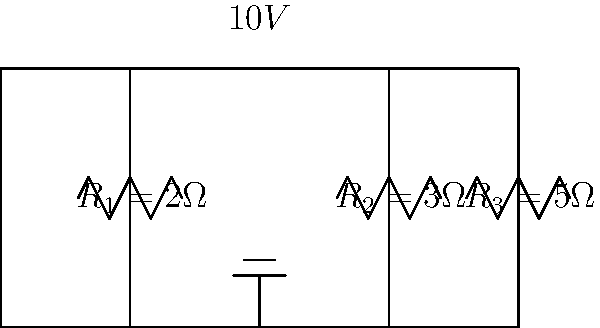As you're preparing your favorite customer's usual latte, you notice a diagram of a series circuit on their electrical engineering textbook. The circuit has a 10V source and three resistors: $R_1 = 2\Omega$, $R_2 = 3\Omega$, and $R_3 = 5\Omega$. What is the voltage drop across $R_2$? Let's approach this step-by-step:

1) In a series circuit, the current is the same throughout the circuit. We need to find this current first.

2) To find the current, we use Ohm's Law: $V = IR$

3) The total resistance in the circuit is the sum of all resistors:
   $R_{total} = R_1 + R_2 + R_3 = 2\Omega + 3\Omega + 5\Omega = 10\Omega$

4) Now we can calculate the current:
   $I = \frac{V}{R_{total}} = \frac{10V}{10\Omega} = 1A$

5) To find the voltage drop across $R_2$, we use Ohm's Law again:
   $V_{R2} = I \times R_2 = 1A \times 3\Omega = 3V$

Therefore, the voltage drop across $R_2$ is 3V.
Answer: $3V$ 